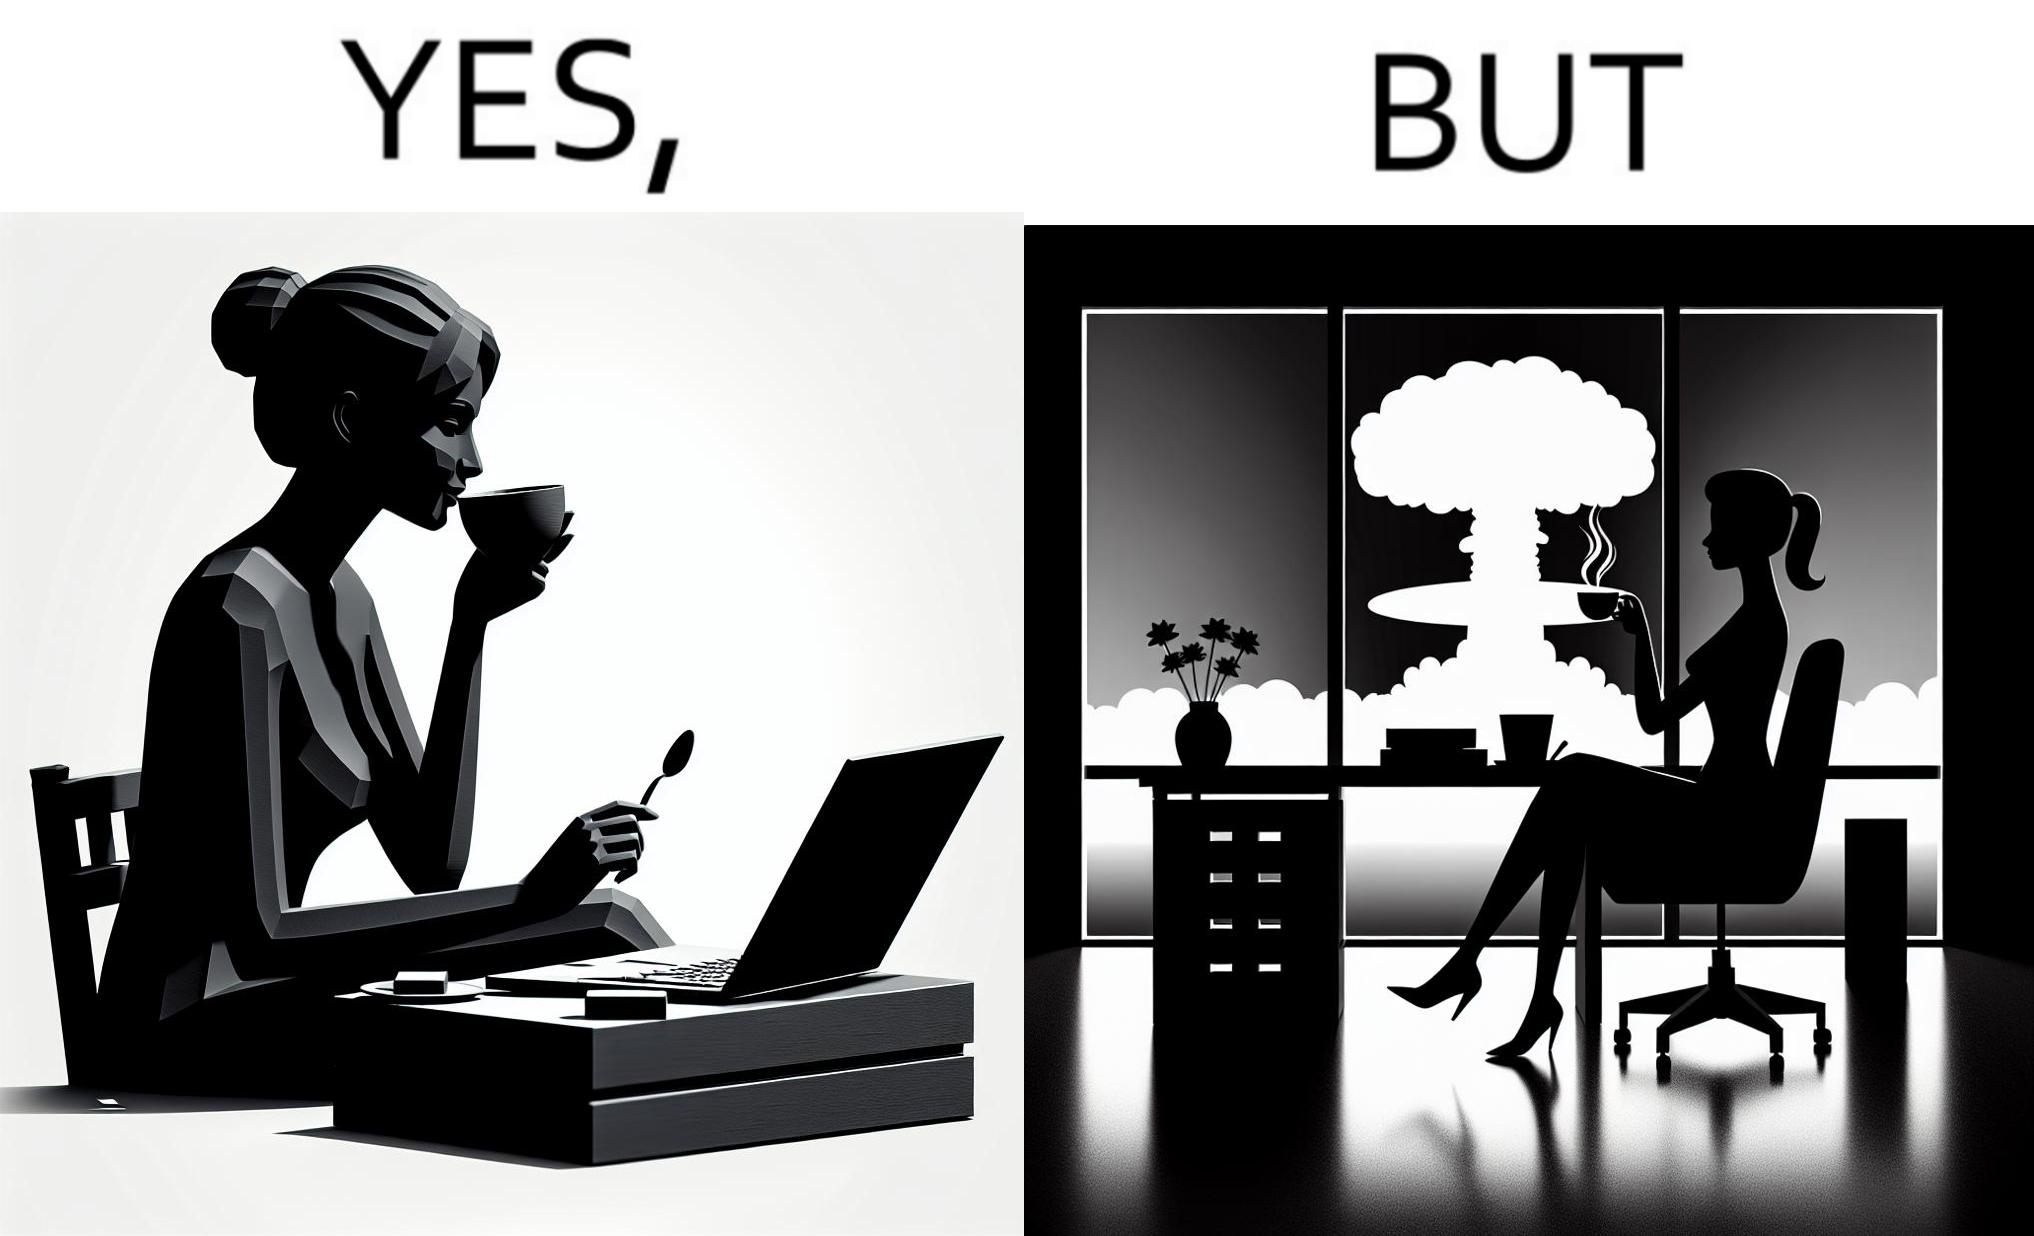Describe the contrast between the left and right parts of this image. In the left part of the image: A woman sipping from a cup in a cafe with her laptop In the right part of the image: A woman sipping from a cup while looking at a nuclear blast from her desk 